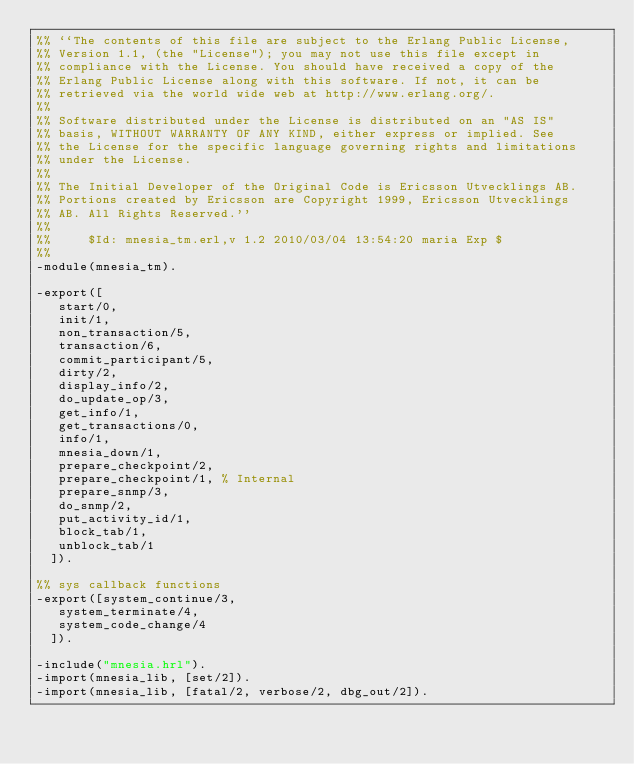Convert code to text. <code><loc_0><loc_0><loc_500><loc_500><_Erlang_>%% ``The contents of this file are subject to the Erlang Public License,
%% Version 1.1, (the "License"); you may not use this file except in
%% compliance with the License. You should have received a copy of the
%% Erlang Public License along with this software. If not, it can be
%% retrieved via the world wide web at http://www.erlang.org/.
%%
%% Software distributed under the License is distributed on an "AS IS"
%% basis, WITHOUT WARRANTY OF ANY KIND, either express or implied. See
%% the License for the specific language governing rights and limitations
%% under the License.
%%
%% The Initial Developer of the Original Code is Ericsson Utvecklings AB.
%% Portions created by Ericsson are Copyright 1999, Ericsson Utvecklings
%% AB. All Rights Reserved.''
%%
%%     $Id: mnesia_tm.erl,v 1.2 2010/03/04 13:54:20 maria Exp $
%%
-module(mnesia_tm).

-export([
	 start/0,
	 init/1,
	 non_transaction/5,
	 transaction/6,
	 commit_participant/5,
	 dirty/2,
	 display_info/2,
	 do_update_op/3,
	 get_info/1,
	 get_transactions/0,
	 info/1,
	 mnesia_down/1,
	 prepare_checkpoint/2,
	 prepare_checkpoint/1, % Internal
	 prepare_snmp/3,
	 do_snmp/2,
	 put_activity_id/1,
	 block_tab/1,
	 unblock_tab/1
	]).

%% sys callback functions
-export([system_continue/3,
	 system_terminate/4,
	 system_code_change/4
	]).

-include("mnesia.hrl").
-import(mnesia_lib, [set/2]).
-import(mnesia_lib, [fatal/2, verbose/2, dbg_out/2]).
</code> 